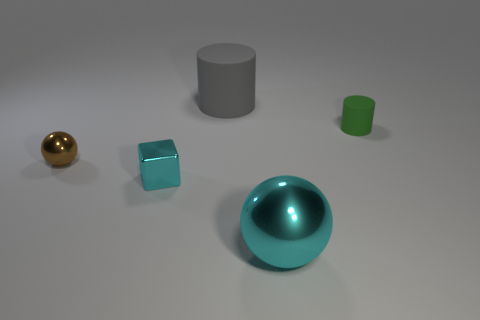Add 1 small shiny things. How many objects exist? 6 Subtract all balls. How many objects are left? 3 Add 5 cyan cylinders. How many cyan cylinders exist? 5 Subtract 0 green balls. How many objects are left? 5 Subtract all large cyan metallic spheres. Subtract all green cylinders. How many objects are left? 3 Add 3 green rubber cylinders. How many green rubber cylinders are left? 4 